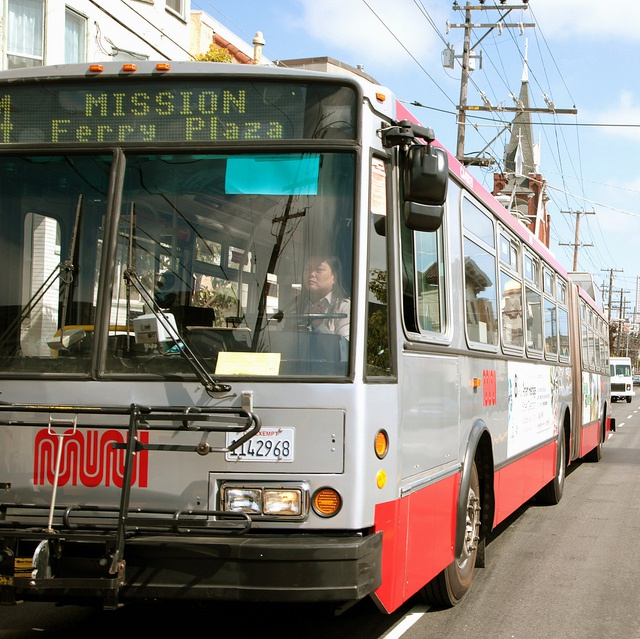Describe the objects in this image and their specific colors. I can see bus in white, black, gray, lightgray, and darkgray tones, people in white, gray, and darkgray tones, and truck in white, black, gray, and darkgray tones in this image. 